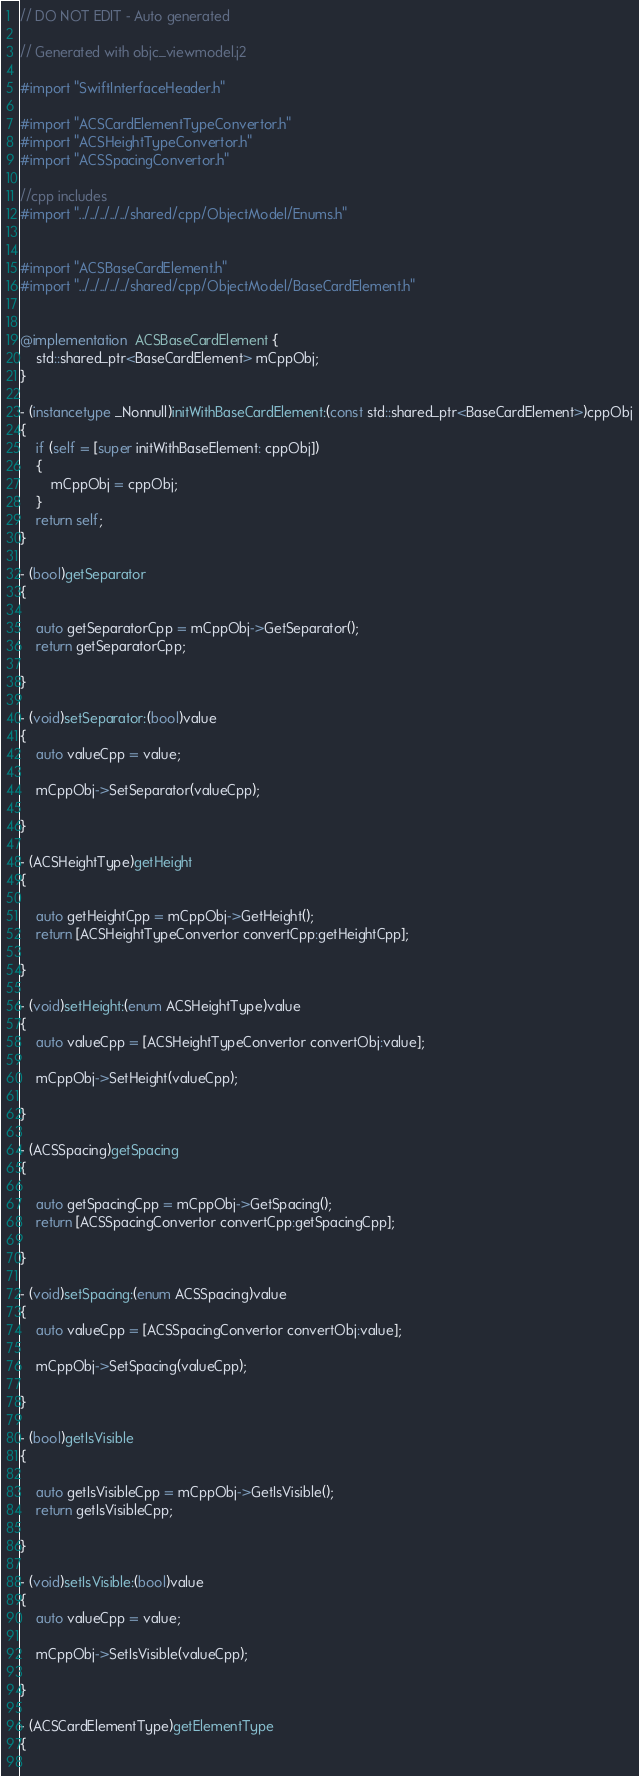Convert code to text. <code><loc_0><loc_0><loc_500><loc_500><_ObjectiveC_>// DO NOT EDIT - Auto generated

// Generated with objc_viewmodel.j2

#import "SwiftInterfaceHeader.h"

#import "ACSCardElementTypeConvertor.h"
#import "ACSHeightTypeConvertor.h"
#import "ACSSpacingConvertor.h"

//cpp includes
#import "../../../../../shared/cpp/ObjectModel/Enums.h"


#import "ACSBaseCardElement.h"
#import "../../../../../shared/cpp/ObjectModel/BaseCardElement.h"


@implementation  ACSBaseCardElement {
    std::shared_ptr<BaseCardElement> mCppObj;
}

- (instancetype _Nonnull)initWithBaseCardElement:(const std::shared_ptr<BaseCardElement>)cppObj
{
    if (self = [super initWithBaseElement: cppObj])
    {
        mCppObj = cppObj;
    }
    return self;
}

- (bool)getSeparator
{
 
    auto getSeparatorCpp = mCppObj->GetSeparator();
    return getSeparatorCpp;

}

- (void)setSeparator:(bool)value
{
    auto valueCpp = value;
 
    mCppObj->SetSeparator(valueCpp);
    
}

- (ACSHeightType)getHeight
{
 
    auto getHeightCpp = mCppObj->GetHeight();
    return [ACSHeightTypeConvertor convertCpp:getHeightCpp];

}

- (void)setHeight:(enum ACSHeightType)value
{
    auto valueCpp = [ACSHeightTypeConvertor convertObj:value];
 
    mCppObj->SetHeight(valueCpp);
    
}

- (ACSSpacing)getSpacing
{
 
    auto getSpacingCpp = mCppObj->GetSpacing();
    return [ACSSpacingConvertor convertCpp:getSpacingCpp];

}

- (void)setSpacing:(enum ACSSpacing)value
{
    auto valueCpp = [ACSSpacingConvertor convertObj:value];
 
    mCppObj->SetSpacing(valueCpp);
    
}

- (bool)getIsVisible
{
 
    auto getIsVisibleCpp = mCppObj->GetIsVisible();
    return getIsVisibleCpp;

}

- (void)setIsVisible:(bool)value
{
    auto valueCpp = value;
 
    mCppObj->SetIsVisible(valueCpp);
    
}

- (ACSCardElementType)getElementType
{
 </code> 